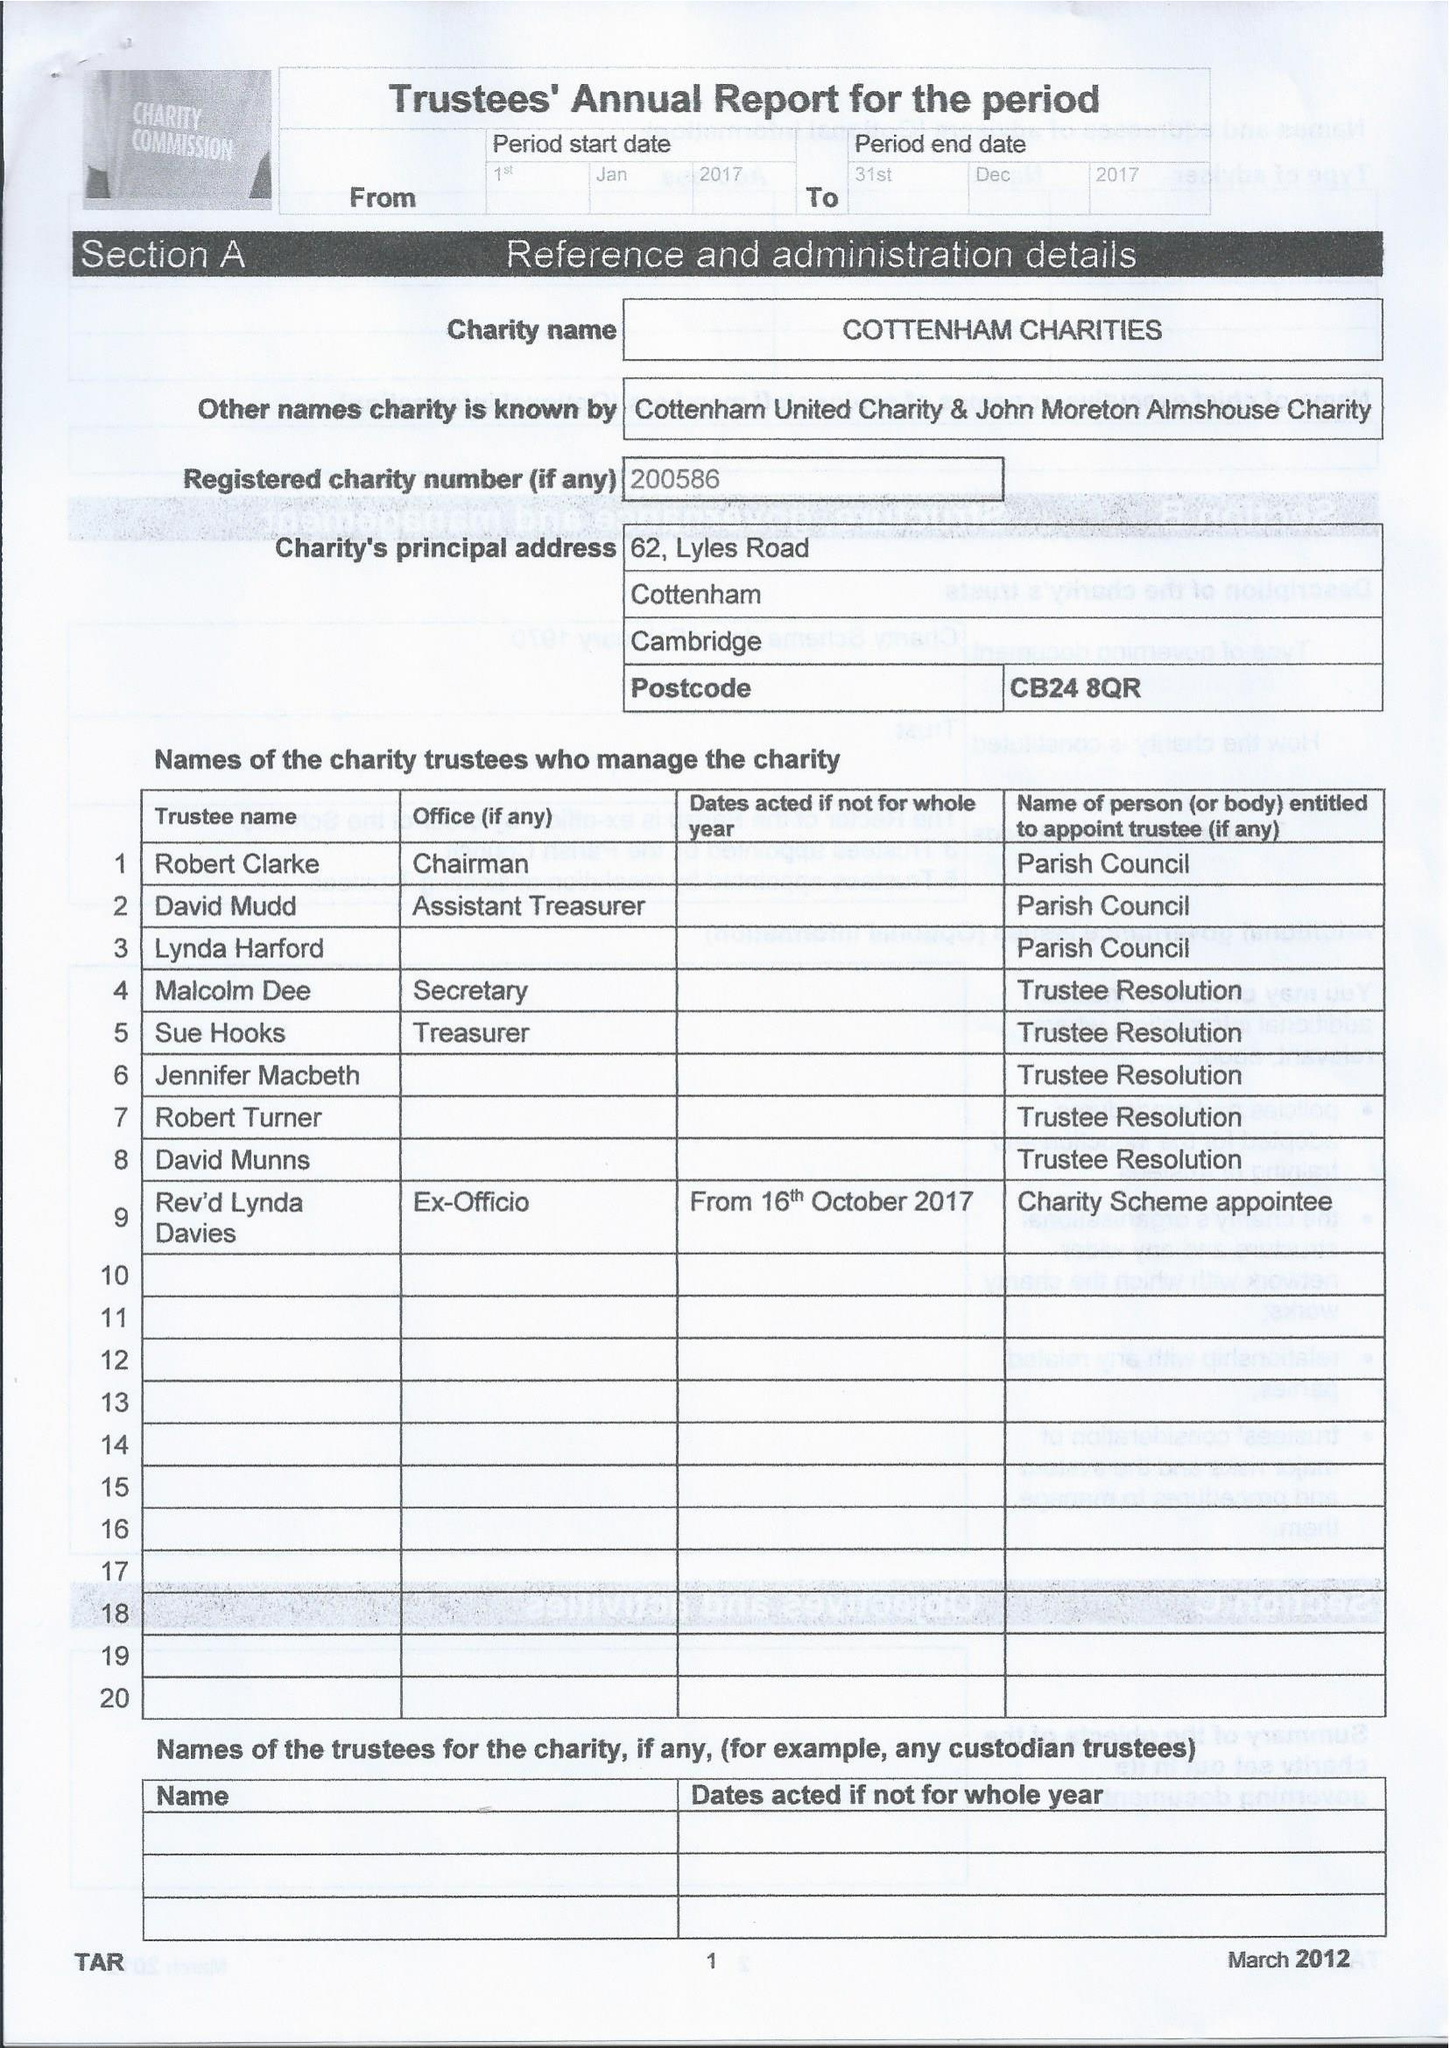What is the value for the address__postcode?
Answer the question using a single word or phrase. CB24 8QR 